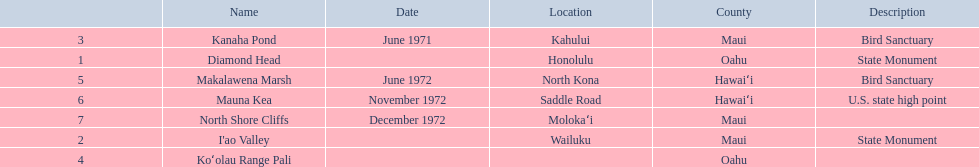What are the national natural landmarks in hawaii? Diamond Head, I'ao Valley, Kanaha Pond, Koʻolau Range Pali, Makalawena Marsh, Mauna Kea, North Shore Cliffs. Which of theses are in hawa'i county? Makalawena Marsh, Mauna Kea. Of these which has a bird sanctuary? Makalawena Marsh. 